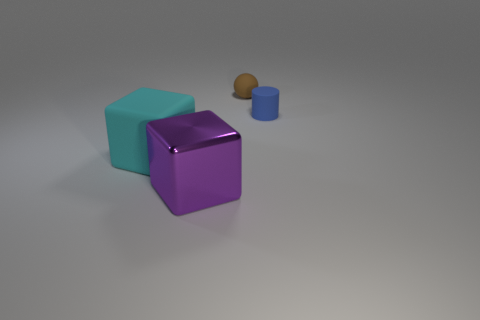Add 1 matte spheres. How many objects exist? 5 Subtract all cylinders. How many objects are left? 3 Subtract all big cyan spheres. Subtract all small things. How many objects are left? 2 Add 1 blue cylinders. How many blue cylinders are left? 2 Add 1 tiny brown spheres. How many tiny brown spheres exist? 2 Subtract all cyan blocks. How many blocks are left? 1 Subtract 0 gray balls. How many objects are left? 4 Subtract 1 blocks. How many blocks are left? 1 Subtract all red cylinders. Subtract all blue balls. How many cylinders are left? 1 Subtract all gray spheres. How many purple cubes are left? 1 